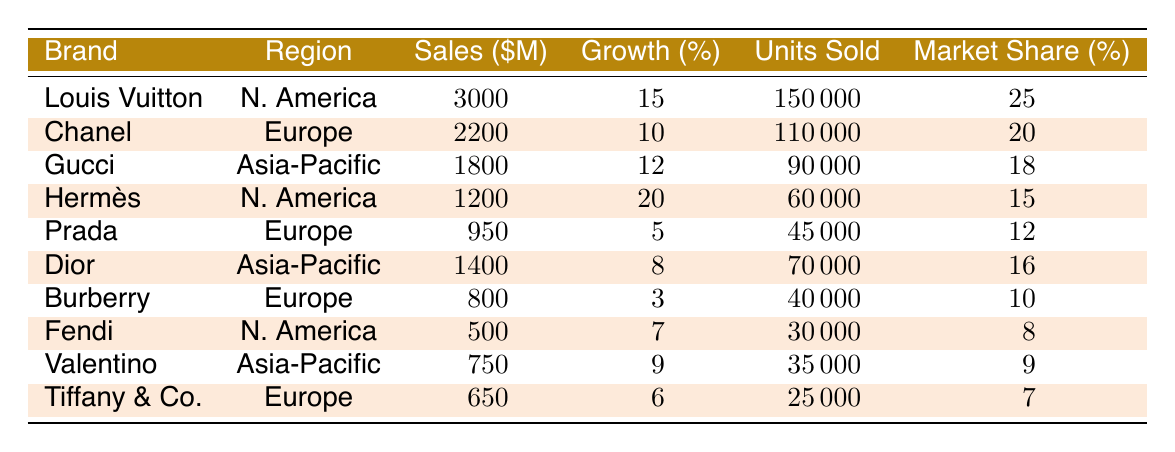What was the highest sales amount among the luxury brands listed? The highest sales amount is found in the first row of the table, which shows Louis Vuitton with sales of 3,000 million dollars.
Answer: 3,000 million dollars Which brand experienced the most significant percentage growth in sales? Hermès in North America had the highest growth at 20%, as indicated in the table.
Answer: Hermès How many units did Chanel sell? The table lists Chanel's units sold as 110,000, which is directly stated in the respective row.
Answer: 110,000 units What is the average sales amount of the brands in Europe? The brands listed in Europe are Chanel, Prada, Burberry, and Tiffany & Co. The total sales are 2,200 + 950 + 800 + 650 = 4,600 million dollars. The average is calculated as 4,600 / 4 = 1,150 million dollars.
Answer: 1,150 million dollars Is the market share of Gucci higher than the market share of Fendi? The table shows Gucci with a market share of 18% and Fendi with 8%. Since 18% is greater than 8%, the statement is true.
Answer: Yes What is the total number of units sold by luxury brands in North America? The brands in North America are Louis Vuitton, Hermès, and Fendi. Their units sold are 150,000 + 60,000 + 30,000 = 240,000 units sold in total.
Answer: 240,000 units Which region had the lowest total sales among the luxury brands? Adding up the sales for Europe, we have 2,200 + 950 + 800 + 650 = 4,600 million dollars. For Asia-Pacific, we find 1,800 + 1,400 + 750 = 3,950 million dollars; North America totals 3,000 + 1,200 + 500 = 4,700 million dollars. The lowest sales region is Asia-Pacific with 3,950 million dollars.
Answer: Asia-Pacific What is the difference in percentage growth between the highest and lowest growth brands? The highest growth is Hermès at 20% and lowest is Burberry at 3%. The difference is 20 - 3 = 17%.
Answer: 17% Which brand sold the least number of units? By reviewing the units sold, Fendi at 30,000 units sold the least compared to all other brands.
Answer: Fendi What was the total market share for all the brands in Asia-Pacific? The total market share for Asia-Pacific is calculated as 18% (Gucci) + 16% (Dior) + 9% (Valentino) = 43%.
Answer: 43% 